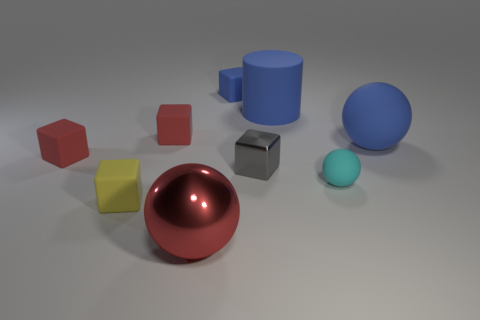Subtract all big blue rubber balls. How many balls are left? 2 Add 1 blue balls. How many objects exist? 10 Subtract all red balls. How many balls are left? 2 Subtract all spheres. How many objects are left? 6 Subtract 0 brown blocks. How many objects are left? 9 Subtract 4 blocks. How many blocks are left? 1 Subtract all blue cubes. Subtract all blue cylinders. How many cubes are left? 4 Subtract all gray balls. How many yellow cubes are left? 1 Subtract all purple spheres. Subtract all large red objects. How many objects are left? 8 Add 2 large blue matte objects. How many large blue matte objects are left? 4 